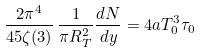<formula> <loc_0><loc_0><loc_500><loc_500>\frac { 2 \pi ^ { 4 } } { 4 5 \zeta ( 3 ) } \, \frac { 1 } { \pi R _ { T } ^ { 2 } } \frac { d N } { d y } = 4 a T _ { 0 } ^ { 3 } \tau _ { 0 }</formula> 